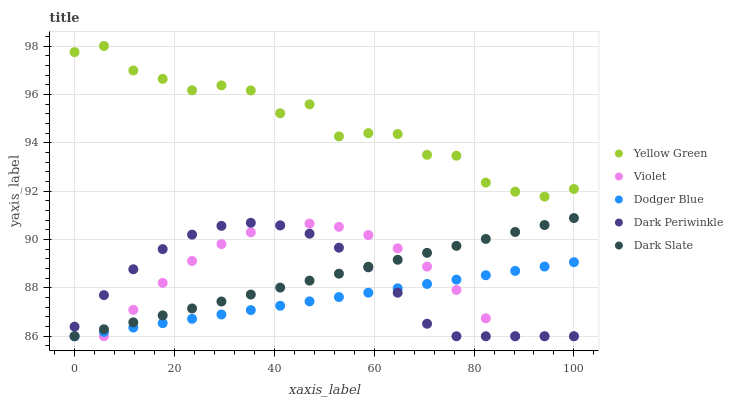Does Dodger Blue have the minimum area under the curve?
Answer yes or no. Yes. Does Yellow Green have the maximum area under the curve?
Answer yes or no. Yes. Does Dark Periwinkle have the minimum area under the curve?
Answer yes or no. No. Does Dark Periwinkle have the maximum area under the curve?
Answer yes or no. No. Is Dodger Blue the smoothest?
Answer yes or no. Yes. Is Yellow Green the roughest?
Answer yes or no. Yes. Is Dark Periwinkle the smoothest?
Answer yes or no. No. Is Dark Periwinkle the roughest?
Answer yes or no. No. Does Dark Slate have the lowest value?
Answer yes or no. Yes. Does Yellow Green have the lowest value?
Answer yes or no. No. Does Yellow Green have the highest value?
Answer yes or no. Yes. Does Dark Periwinkle have the highest value?
Answer yes or no. No. Is Dark Slate less than Yellow Green?
Answer yes or no. Yes. Is Yellow Green greater than Dodger Blue?
Answer yes or no. Yes. Does Violet intersect Dark Periwinkle?
Answer yes or no. Yes. Is Violet less than Dark Periwinkle?
Answer yes or no. No. Is Violet greater than Dark Periwinkle?
Answer yes or no. No. Does Dark Slate intersect Yellow Green?
Answer yes or no. No. 